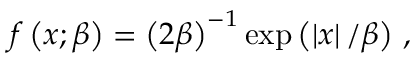Convert formula to latex. <formula><loc_0><loc_0><loc_500><loc_500>f \left ( x ; \beta \right ) = \left ( 2 \beta \right ) ^ { - 1 } \exp \left ( \left | x \right | / \beta \right ) \, ,</formula> 